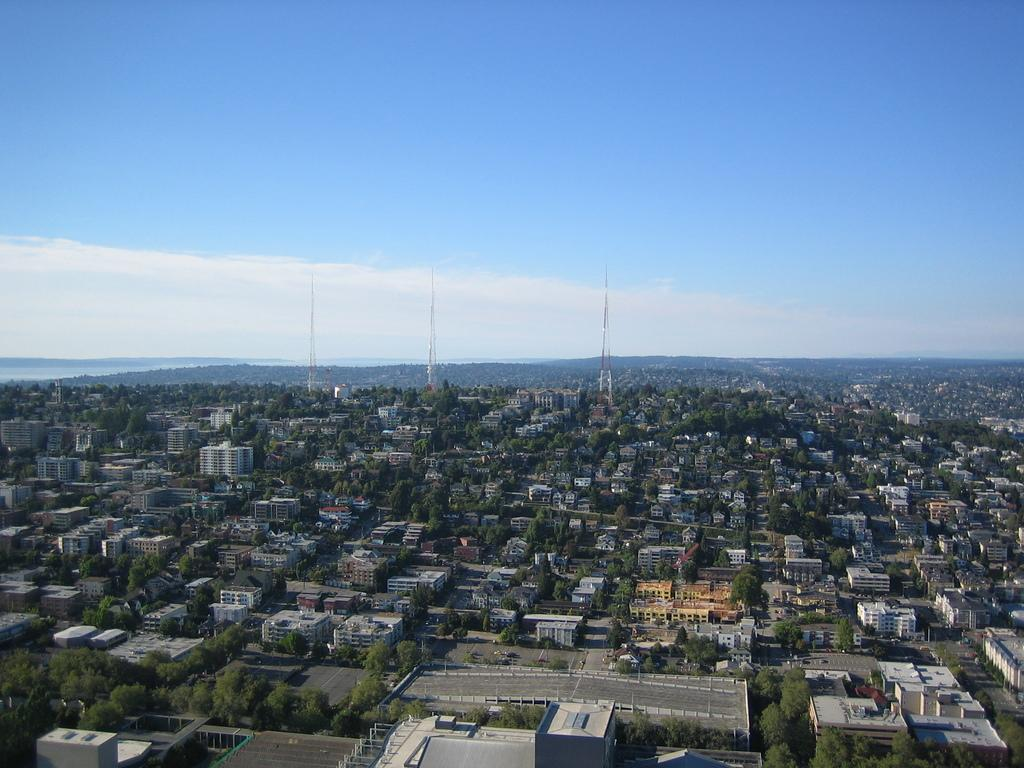What type of view is shown in the image? The image is an aerial view. What can be seen in the image from this perspective? There are many buildings, trees, and towers visible in the image. What is visible in the background of the image? There are hills and the sky visible in the background of the image. What color is the butter on the trees in the image? There is no butter present in the image; it features an aerial view of buildings, trees, and towers. 